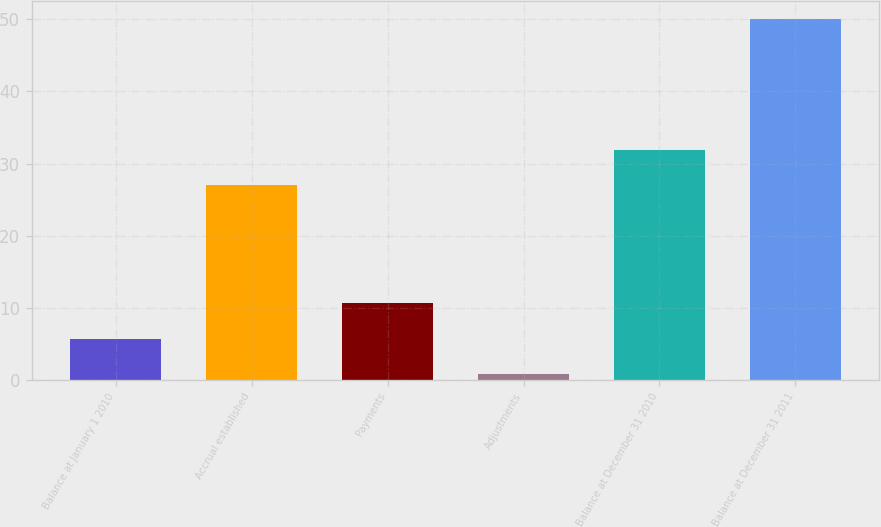Convert chart. <chart><loc_0><loc_0><loc_500><loc_500><bar_chart><fcel>Balance at January 1 2010<fcel>Accrual established<fcel>Payments<fcel>Adjustments<fcel>Balance at December 31 2010<fcel>Balance at December 31 2011<nl><fcel>5.66<fcel>27<fcel>10.59<fcel>0.73<fcel>31.93<fcel>50<nl></chart> 